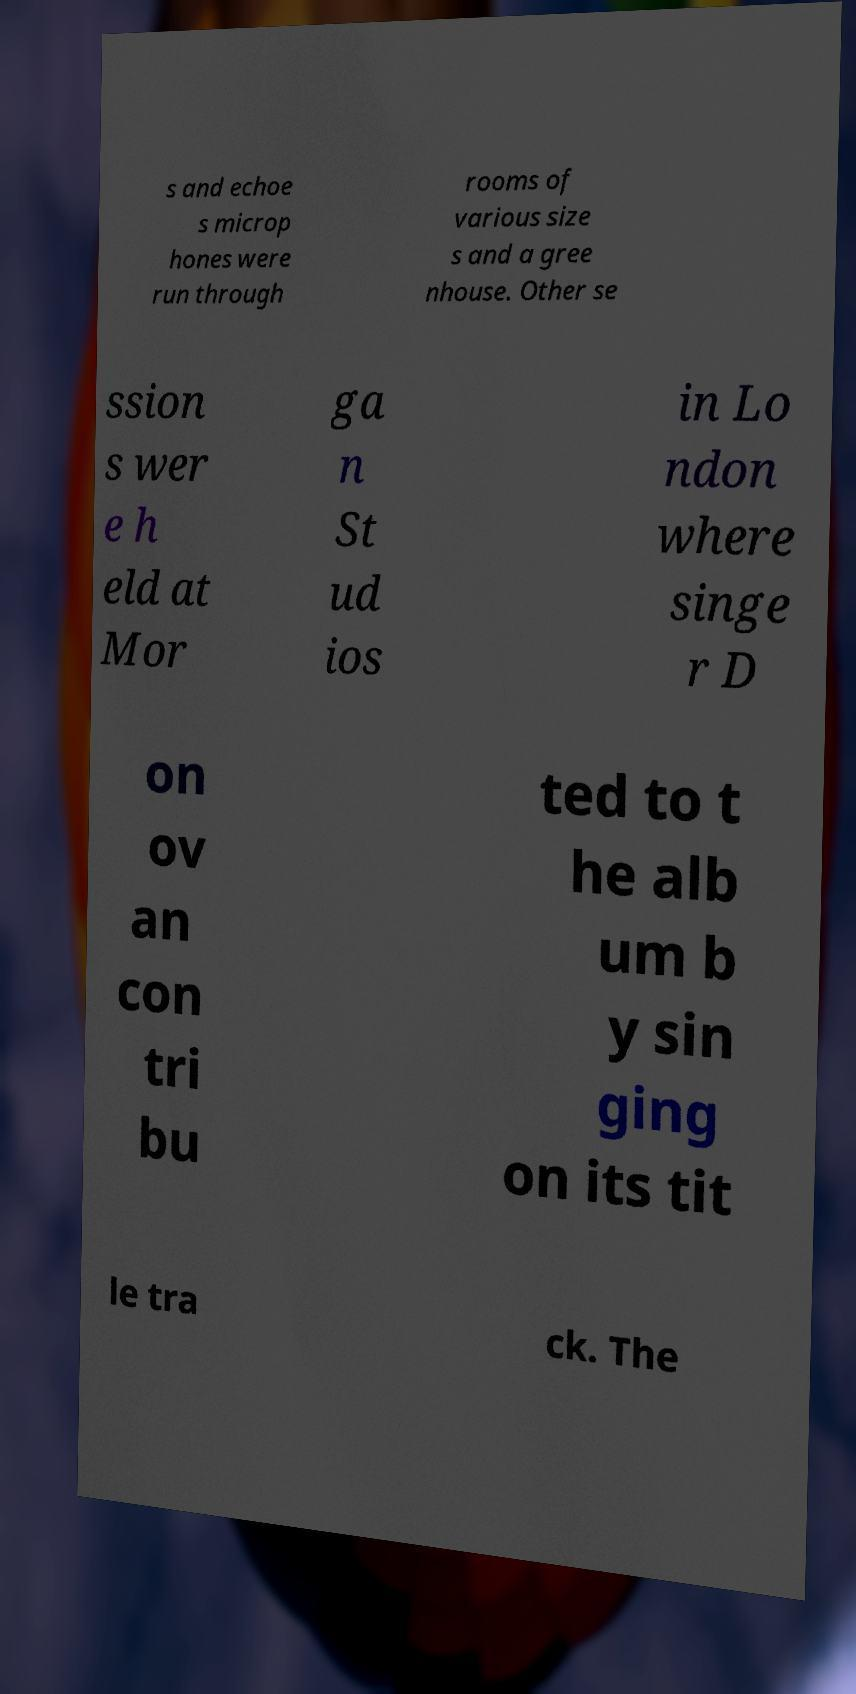For documentation purposes, I need the text within this image transcribed. Could you provide that? s and echoe s microp hones were run through rooms of various size s and a gree nhouse. Other se ssion s wer e h eld at Mor ga n St ud ios in Lo ndon where singe r D on ov an con tri bu ted to t he alb um b y sin ging on its tit le tra ck. The 